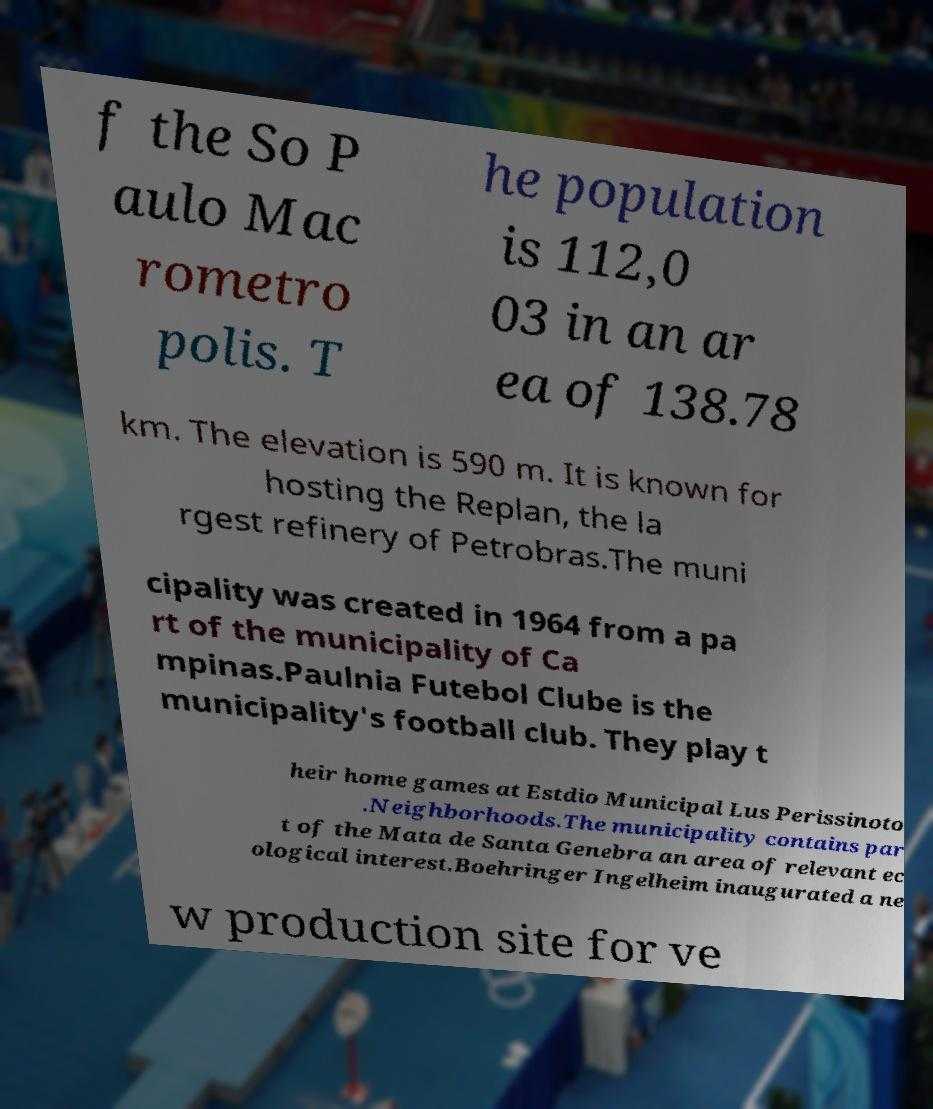There's text embedded in this image that I need extracted. Can you transcribe it verbatim? f the So P aulo Mac rometro polis. T he population is 112,0 03 in an ar ea of 138.78 km. The elevation is 590 m. It is known for hosting the Replan, the la rgest refinery of Petrobras.The muni cipality was created in 1964 from a pa rt of the municipality of Ca mpinas.Paulnia Futebol Clube is the municipality's football club. They play t heir home games at Estdio Municipal Lus Perissinoto .Neighborhoods.The municipality contains par t of the Mata de Santa Genebra an area of relevant ec ological interest.Boehringer Ingelheim inaugurated a ne w production site for ve 